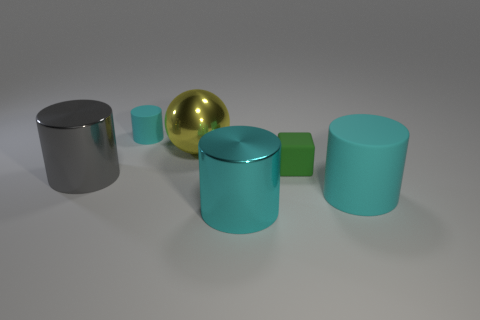Subtract all brown balls. How many cyan cylinders are left? 3 Subtract all yellow cylinders. Subtract all blue cubes. How many cylinders are left? 4 Add 4 shiny balls. How many objects exist? 10 Subtract all cubes. How many objects are left? 5 Add 4 balls. How many balls are left? 5 Add 3 rubber cubes. How many rubber cubes exist? 4 Subtract 0 blue cubes. How many objects are left? 6 Subtract all large gray metallic cylinders. Subtract all cyan cylinders. How many objects are left? 2 